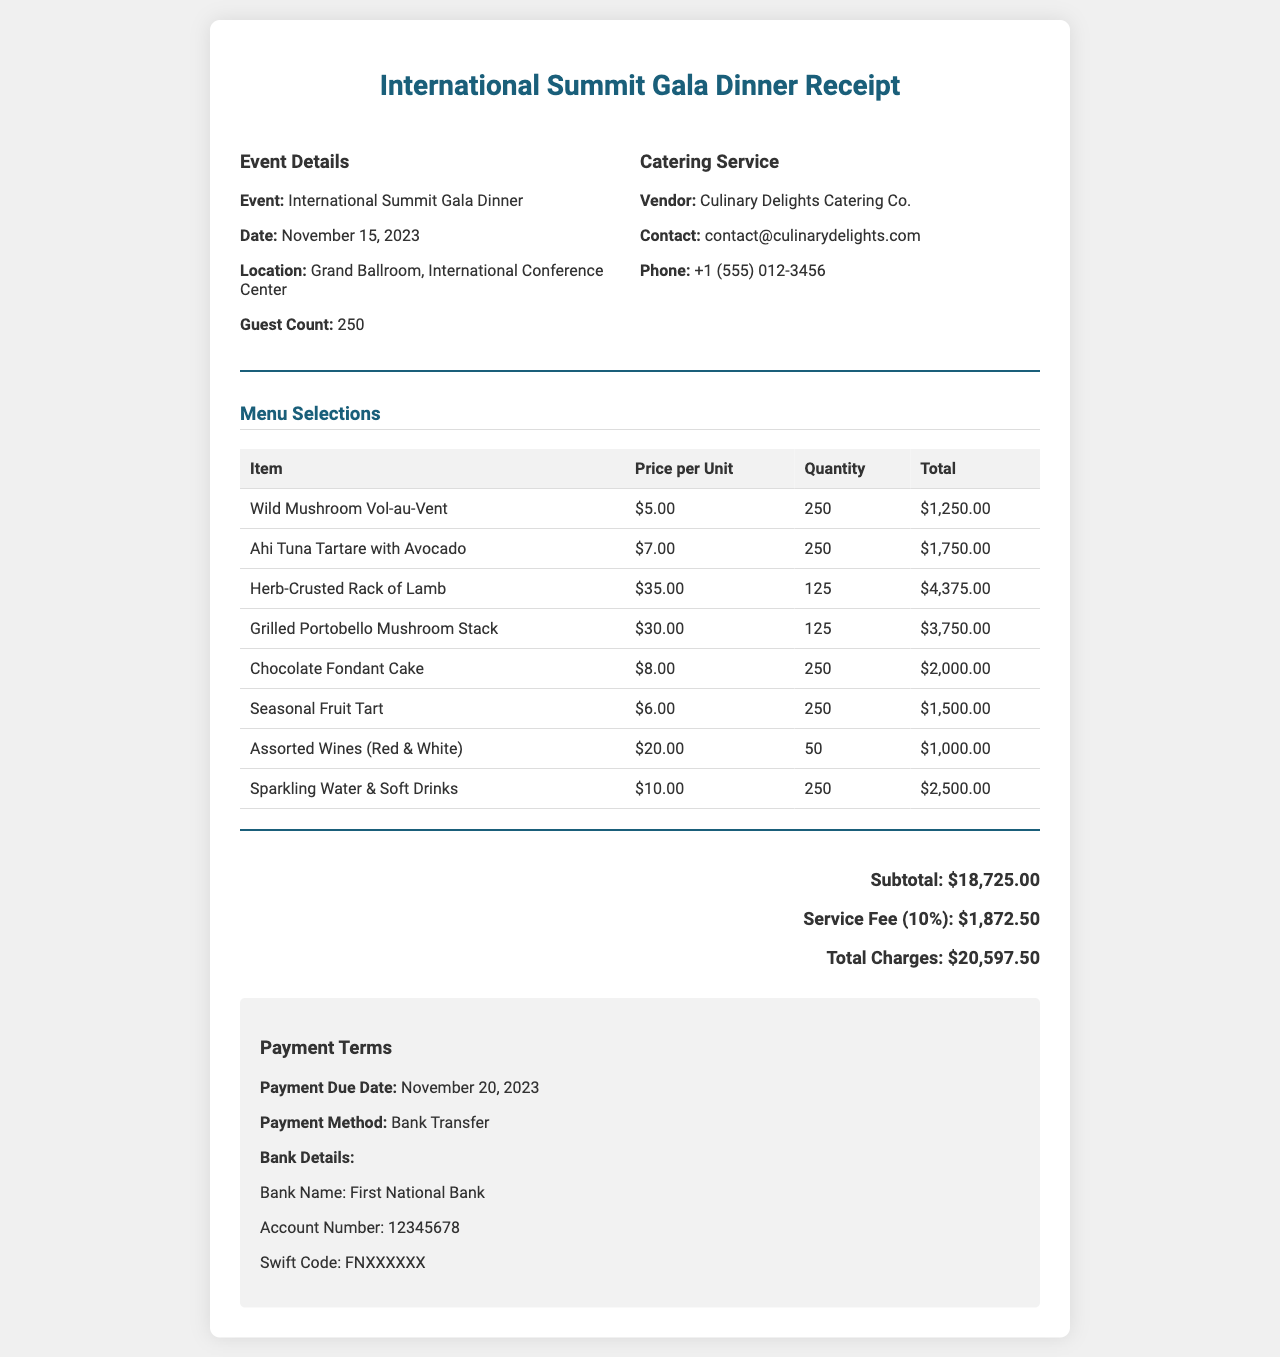What is the date of the gala dinner? The date of the gala dinner is specified in the document as November 15, 2023.
Answer: November 15, 2023 Who is the catering service vendor? The vendor providing catering services is mentioned as Culinary Delights Catering Co.
Answer: Culinary Delights Catering Co How many guests are expected at the event? The document states the guest count as 250.
Answer: 250 What is the total charge for the gala dinner? The total charges, including subtotal and service fee, amount to $20,597.50 as detailed in the document.
Answer: $20,597.50 What is the service fee percentage? The service fee is indicated as 10% of the subtotal.
Answer: 10% How many Ahi Tuna Tartare with Avocado will be served? The quantity of Ahi Tuna Tartare with Avocado is listed as 250 in the menu selections.
Answer: 250 What payment method is specified? The document states that payments will be made via Bank Transfer.
Answer: Bank Transfer When is the payment due date? The receipt specifies the payment due date as November 20, 2023.
Answer: November 20, 2023 What is the subtotal amount before the service fee? The subtotal amount provided in the document is $18,725.00.
Answer: $18,725.00 